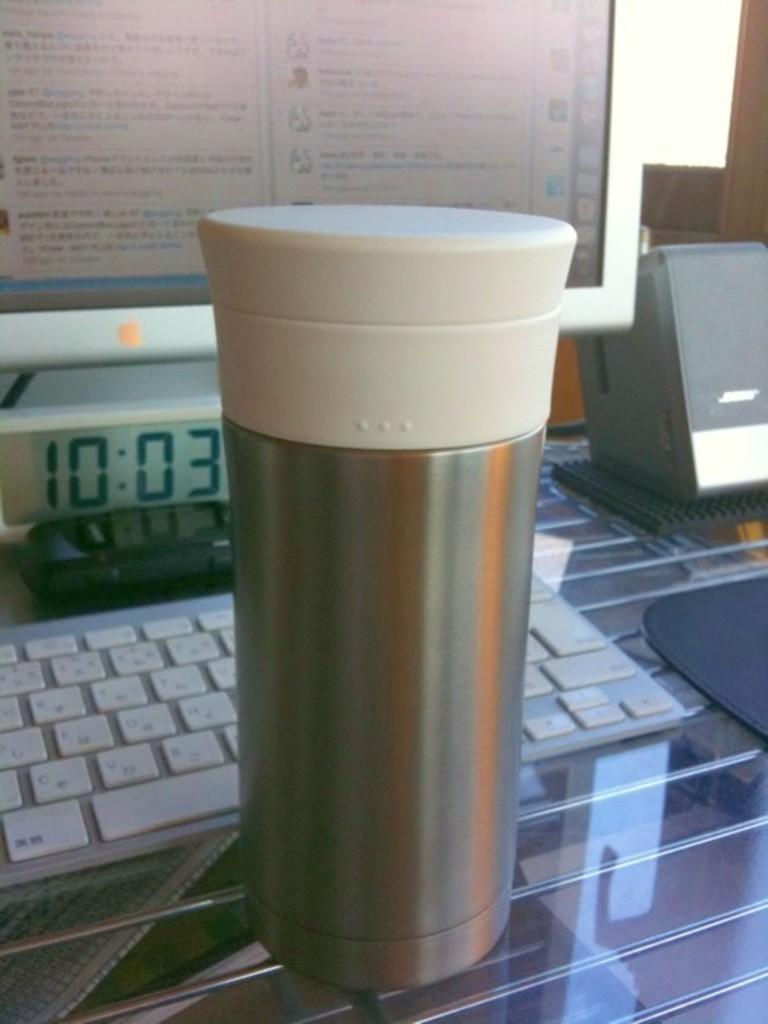<image>
Offer a succinct explanation of the picture presented. a striped thermos in front of a monitor and clock reading 10:03 